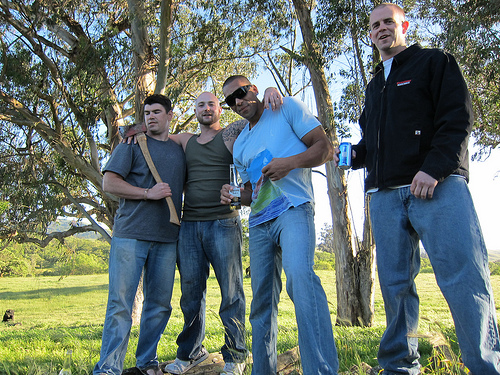<image>
Is the man behind the tree? No. The man is not behind the tree. From this viewpoint, the man appears to be positioned elsewhere in the scene. Is there a pepsi bottle behind the stone? No. The pepsi bottle is not behind the stone. From this viewpoint, the pepsi bottle appears to be positioned elsewhere in the scene. 